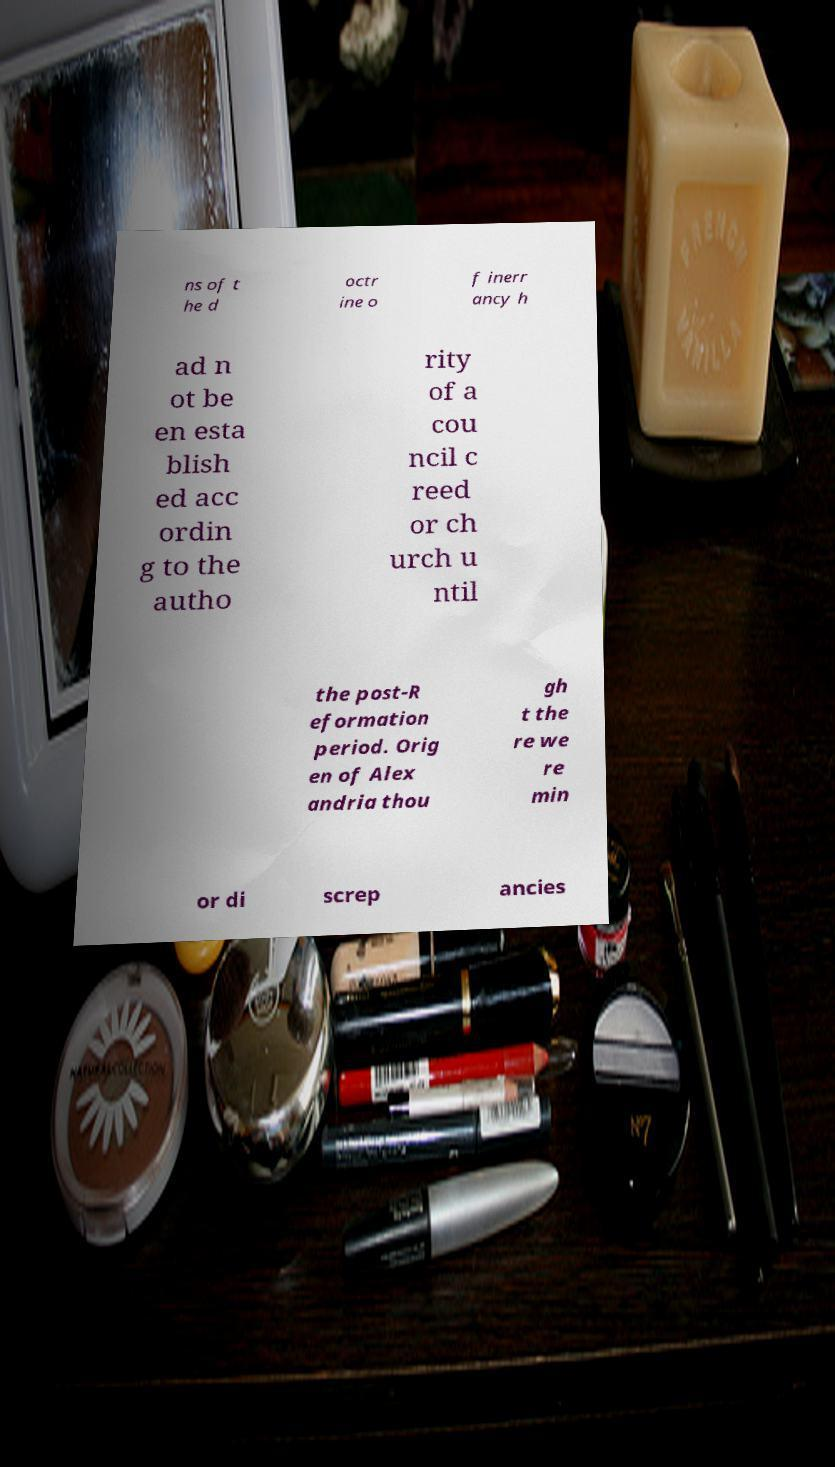Please read and relay the text visible in this image. What does it say? ns of t he d octr ine o f inerr ancy h ad n ot be en esta blish ed acc ordin g to the autho rity of a cou ncil c reed or ch urch u ntil the post-R eformation period. Orig en of Alex andria thou gh t the re we re min or di screp ancies 